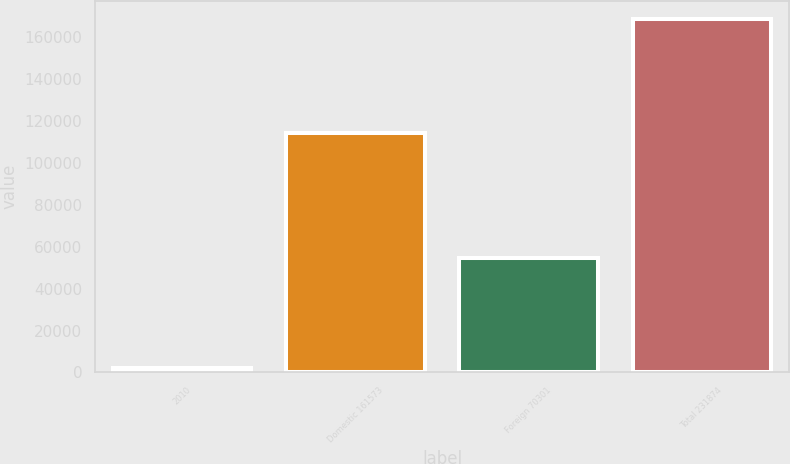Convert chart to OTSL. <chart><loc_0><loc_0><loc_500><loc_500><bar_chart><fcel>2010<fcel>Domestic 161573<fcel>Foreign 70301<fcel>Total 231874<nl><fcel>2009<fcel>114389<fcel>54438<fcel>168827<nl></chart> 